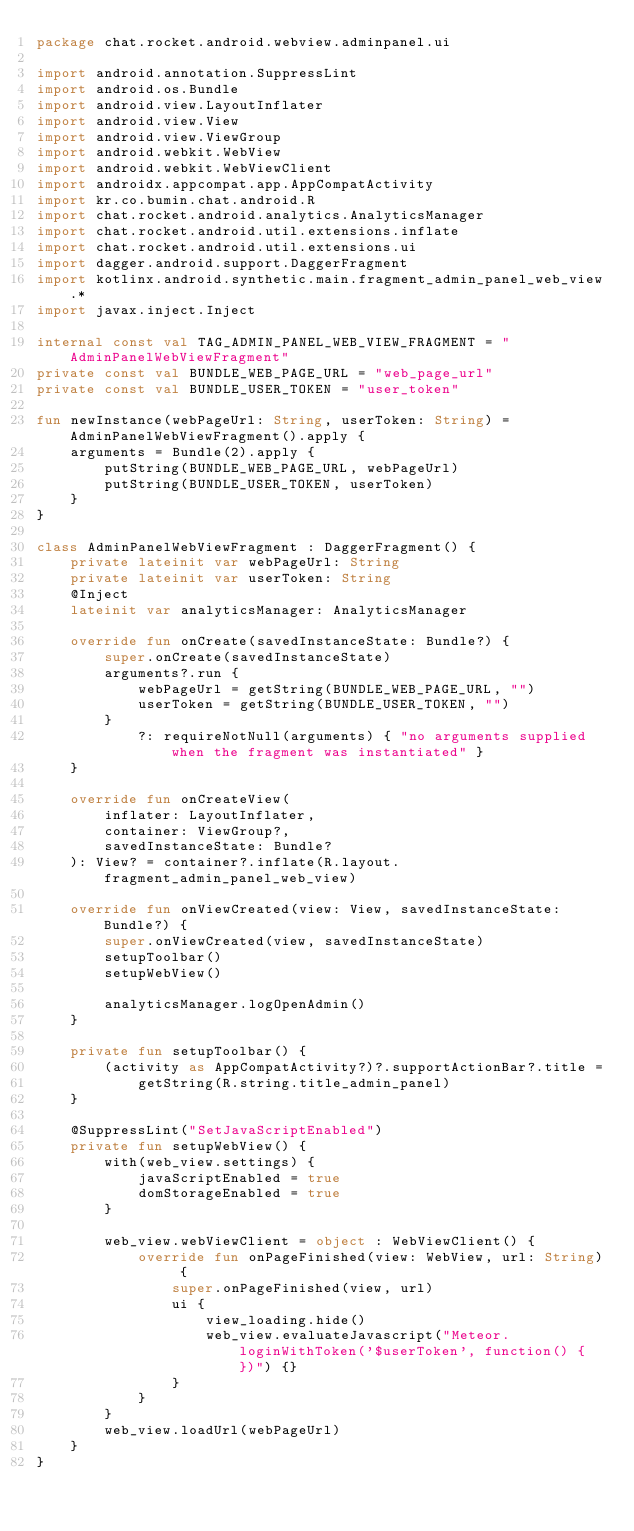<code> <loc_0><loc_0><loc_500><loc_500><_Kotlin_>package chat.rocket.android.webview.adminpanel.ui

import android.annotation.SuppressLint
import android.os.Bundle
import android.view.LayoutInflater
import android.view.View
import android.view.ViewGroup
import android.webkit.WebView
import android.webkit.WebViewClient
import androidx.appcompat.app.AppCompatActivity
import kr.co.bumin.chat.android.R
import chat.rocket.android.analytics.AnalyticsManager
import chat.rocket.android.util.extensions.inflate
import chat.rocket.android.util.extensions.ui
import dagger.android.support.DaggerFragment
import kotlinx.android.synthetic.main.fragment_admin_panel_web_view.*
import javax.inject.Inject

internal const val TAG_ADMIN_PANEL_WEB_VIEW_FRAGMENT = "AdminPanelWebViewFragment"
private const val BUNDLE_WEB_PAGE_URL = "web_page_url"
private const val BUNDLE_USER_TOKEN = "user_token"

fun newInstance(webPageUrl: String, userToken: String) = AdminPanelWebViewFragment().apply {
    arguments = Bundle(2).apply {
        putString(BUNDLE_WEB_PAGE_URL, webPageUrl)
        putString(BUNDLE_USER_TOKEN, userToken)
    }
}

class AdminPanelWebViewFragment : DaggerFragment() {
    private lateinit var webPageUrl: String
    private lateinit var userToken: String
    @Inject
    lateinit var analyticsManager: AnalyticsManager

    override fun onCreate(savedInstanceState: Bundle?) {
        super.onCreate(savedInstanceState)
        arguments?.run {
            webPageUrl = getString(BUNDLE_WEB_PAGE_URL, "")
            userToken = getString(BUNDLE_USER_TOKEN, "")
        }
            ?: requireNotNull(arguments) { "no arguments supplied when the fragment was instantiated" }
    }

    override fun onCreateView(
        inflater: LayoutInflater,
        container: ViewGroup?,
        savedInstanceState: Bundle?
    ): View? = container?.inflate(R.layout.fragment_admin_panel_web_view)

    override fun onViewCreated(view: View, savedInstanceState: Bundle?) {
        super.onViewCreated(view, savedInstanceState)
        setupToolbar()
        setupWebView()

        analyticsManager.logOpenAdmin()
    }

    private fun setupToolbar() {
        (activity as AppCompatActivity?)?.supportActionBar?.title =
            getString(R.string.title_admin_panel)
    }

    @SuppressLint("SetJavaScriptEnabled")
    private fun setupWebView() {
        with(web_view.settings) {
            javaScriptEnabled = true
            domStorageEnabled = true
        }

        web_view.webViewClient = object : WebViewClient() {
            override fun onPageFinished(view: WebView, url: String) {
                super.onPageFinished(view, url)
                ui {
                    view_loading.hide()
                    web_view.evaluateJavascript("Meteor.loginWithToken('$userToken', function() { })") {}
                }
            }
        }
        web_view.loadUrl(webPageUrl)
    }
}</code> 